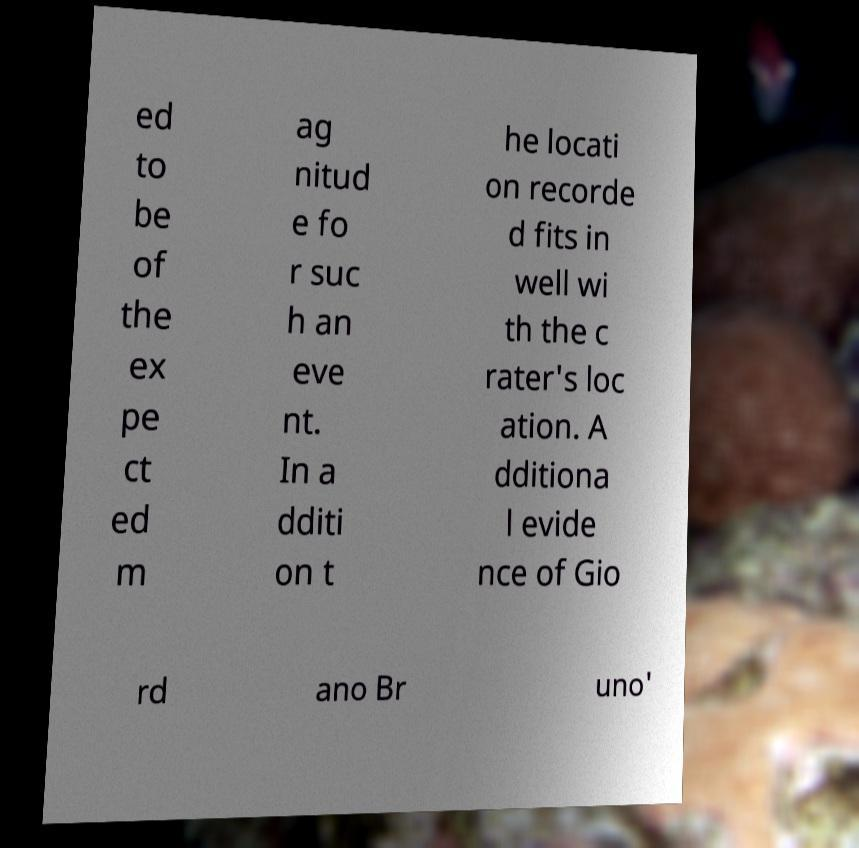For documentation purposes, I need the text within this image transcribed. Could you provide that? ed to be of the ex pe ct ed m ag nitud e fo r suc h an eve nt. In a dditi on t he locati on recorde d fits in well wi th the c rater's loc ation. A dditiona l evide nce of Gio rd ano Br uno' 